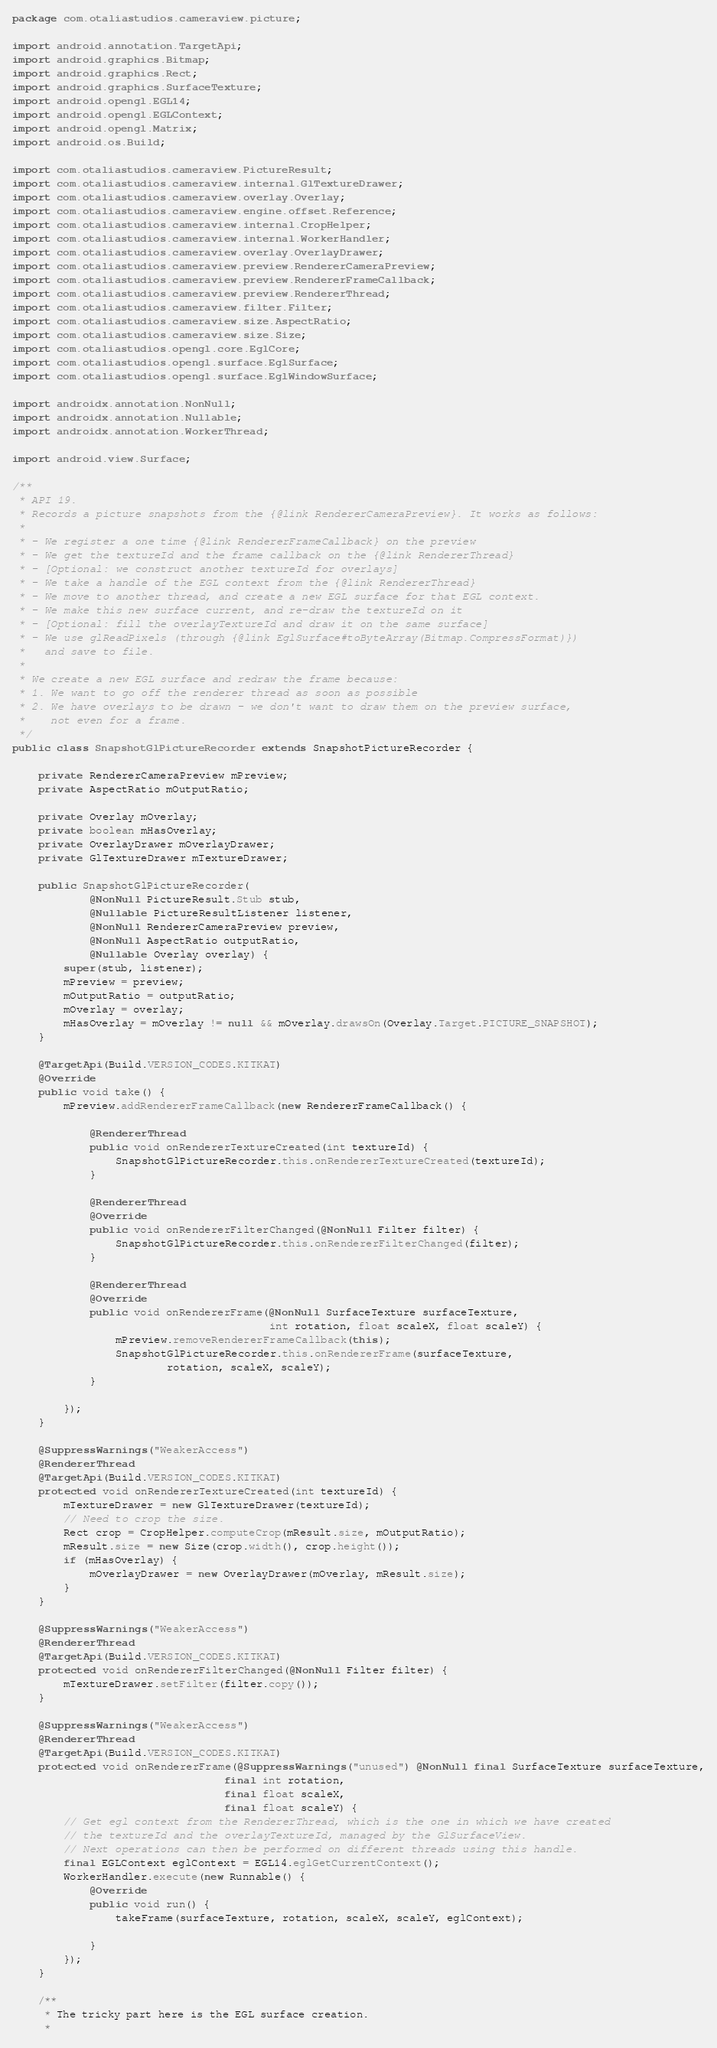<code> <loc_0><loc_0><loc_500><loc_500><_Java_>package com.otaliastudios.cameraview.picture;

import android.annotation.TargetApi;
import android.graphics.Bitmap;
import android.graphics.Rect;
import android.graphics.SurfaceTexture;
import android.opengl.EGL14;
import android.opengl.EGLContext;
import android.opengl.Matrix;
import android.os.Build;

import com.otaliastudios.cameraview.PictureResult;
import com.otaliastudios.cameraview.internal.GlTextureDrawer;
import com.otaliastudios.cameraview.overlay.Overlay;
import com.otaliastudios.cameraview.engine.offset.Reference;
import com.otaliastudios.cameraview.internal.CropHelper;
import com.otaliastudios.cameraview.internal.WorkerHandler;
import com.otaliastudios.cameraview.overlay.OverlayDrawer;
import com.otaliastudios.cameraview.preview.RendererCameraPreview;
import com.otaliastudios.cameraview.preview.RendererFrameCallback;
import com.otaliastudios.cameraview.preview.RendererThread;
import com.otaliastudios.cameraview.filter.Filter;
import com.otaliastudios.cameraview.size.AspectRatio;
import com.otaliastudios.cameraview.size.Size;
import com.otaliastudios.opengl.core.EglCore;
import com.otaliastudios.opengl.surface.EglSurface;
import com.otaliastudios.opengl.surface.EglWindowSurface;

import androidx.annotation.NonNull;
import androidx.annotation.Nullable;
import androidx.annotation.WorkerThread;

import android.view.Surface;

/**
 * API 19.
 * Records a picture snapshots from the {@link RendererCameraPreview}. It works as follows:
 *
 * - We register a one time {@link RendererFrameCallback} on the preview
 * - We get the textureId and the frame callback on the {@link RendererThread}
 * - [Optional: we construct another textureId for overlays]
 * - We take a handle of the EGL context from the {@link RendererThread}
 * - We move to another thread, and create a new EGL surface for that EGL context.
 * - We make this new surface current, and re-draw the textureId on it
 * - [Optional: fill the overlayTextureId and draw it on the same surface]
 * - We use glReadPixels (through {@link EglSurface#toByteArray(Bitmap.CompressFormat)})
 *   and save to file.
 *
 * We create a new EGL surface and redraw the frame because:
 * 1. We want to go off the renderer thread as soon as possible
 * 2. We have overlays to be drawn - we don't want to draw them on the preview surface,
 *    not even for a frame.
 */
public class SnapshotGlPictureRecorder extends SnapshotPictureRecorder {

    private RendererCameraPreview mPreview;
    private AspectRatio mOutputRatio;

    private Overlay mOverlay;
    private boolean mHasOverlay;
    private OverlayDrawer mOverlayDrawer;
    private GlTextureDrawer mTextureDrawer;

    public SnapshotGlPictureRecorder(
            @NonNull PictureResult.Stub stub,
            @Nullable PictureResultListener listener,
            @NonNull RendererCameraPreview preview,
            @NonNull AspectRatio outputRatio,
            @Nullable Overlay overlay) {
        super(stub, listener);
        mPreview = preview;
        mOutputRatio = outputRatio;
        mOverlay = overlay;
        mHasOverlay = mOverlay != null && mOverlay.drawsOn(Overlay.Target.PICTURE_SNAPSHOT);
    }

    @TargetApi(Build.VERSION_CODES.KITKAT)
    @Override
    public void take() {
        mPreview.addRendererFrameCallback(new RendererFrameCallback() {

            @RendererThread
            public void onRendererTextureCreated(int textureId) {
                SnapshotGlPictureRecorder.this.onRendererTextureCreated(textureId);
            }

            @RendererThread
            @Override
            public void onRendererFilterChanged(@NonNull Filter filter) {
                SnapshotGlPictureRecorder.this.onRendererFilterChanged(filter);
            }

            @RendererThread
            @Override
            public void onRendererFrame(@NonNull SurfaceTexture surfaceTexture,
                                        int rotation, float scaleX, float scaleY) {
                mPreview.removeRendererFrameCallback(this);
                SnapshotGlPictureRecorder.this.onRendererFrame(surfaceTexture,
                        rotation, scaleX, scaleY);
            }

        });
    }

    @SuppressWarnings("WeakerAccess")
    @RendererThread
    @TargetApi(Build.VERSION_CODES.KITKAT)
    protected void onRendererTextureCreated(int textureId) {
        mTextureDrawer = new GlTextureDrawer(textureId);
        // Need to crop the size.
        Rect crop = CropHelper.computeCrop(mResult.size, mOutputRatio);
        mResult.size = new Size(crop.width(), crop.height());
        if (mHasOverlay) {
            mOverlayDrawer = new OverlayDrawer(mOverlay, mResult.size);
        }
    }

    @SuppressWarnings("WeakerAccess")
    @RendererThread
    @TargetApi(Build.VERSION_CODES.KITKAT)
    protected void onRendererFilterChanged(@NonNull Filter filter) {
        mTextureDrawer.setFilter(filter.copy());
    }

    @SuppressWarnings("WeakerAccess")
    @RendererThread
    @TargetApi(Build.VERSION_CODES.KITKAT)
    protected void onRendererFrame(@SuppressWarnings("unused") @NonNull final SurfaceTexture surfaceTexture,
                                 final int rotation,
                                 final float scaleX,
                                 final float scaleY) {
        // Get egl context from the RendererThread, which is the one in which we have created
        // the textureId and the overlayTextureId, managed by the GlSurfaceView.
        // Next operations can then be performed on different threads using this handle.
        final EGLContext eglContext = EGL14.eglGetCurrentContext();
        WorkerHandler.execute(new Runnable() {
            @Override
            public void run() {
                takeFrame(surfaceTexture, rotation, scaleX, scaleY, eglContext);

            }
        });
    }

    /**
     * The tricky part here is the EGL surface creation.
     *</code> 